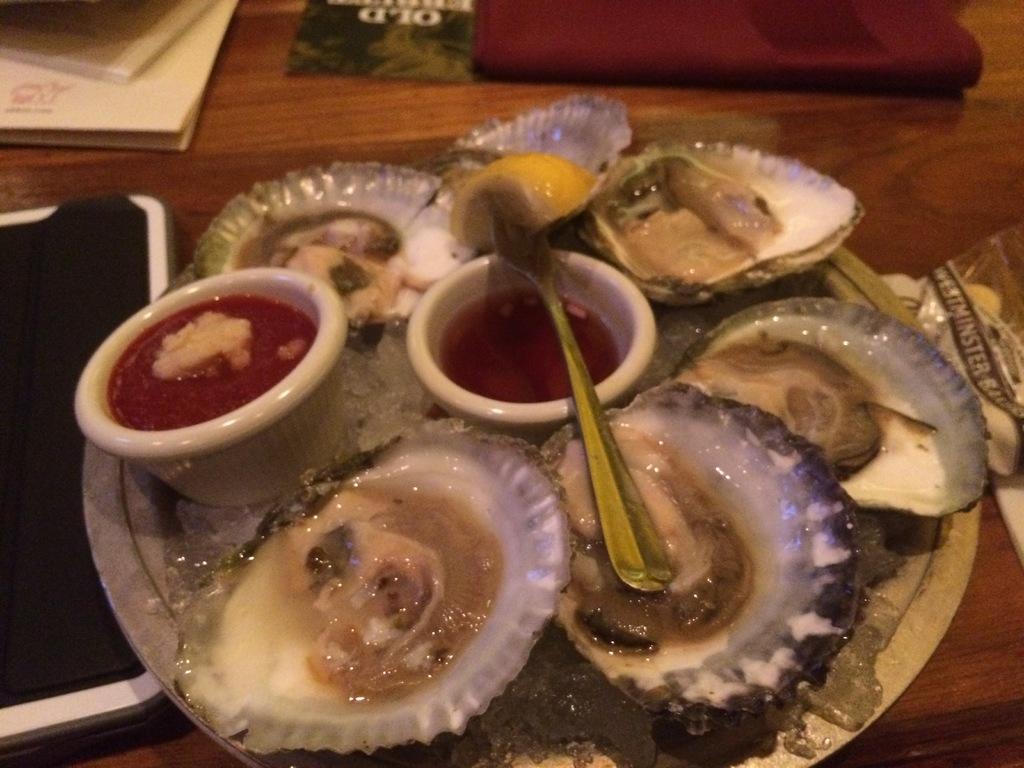Can you describe this image briefly? In this picture we can see plate, food, bowls, shells and objects on the wooden platform. 